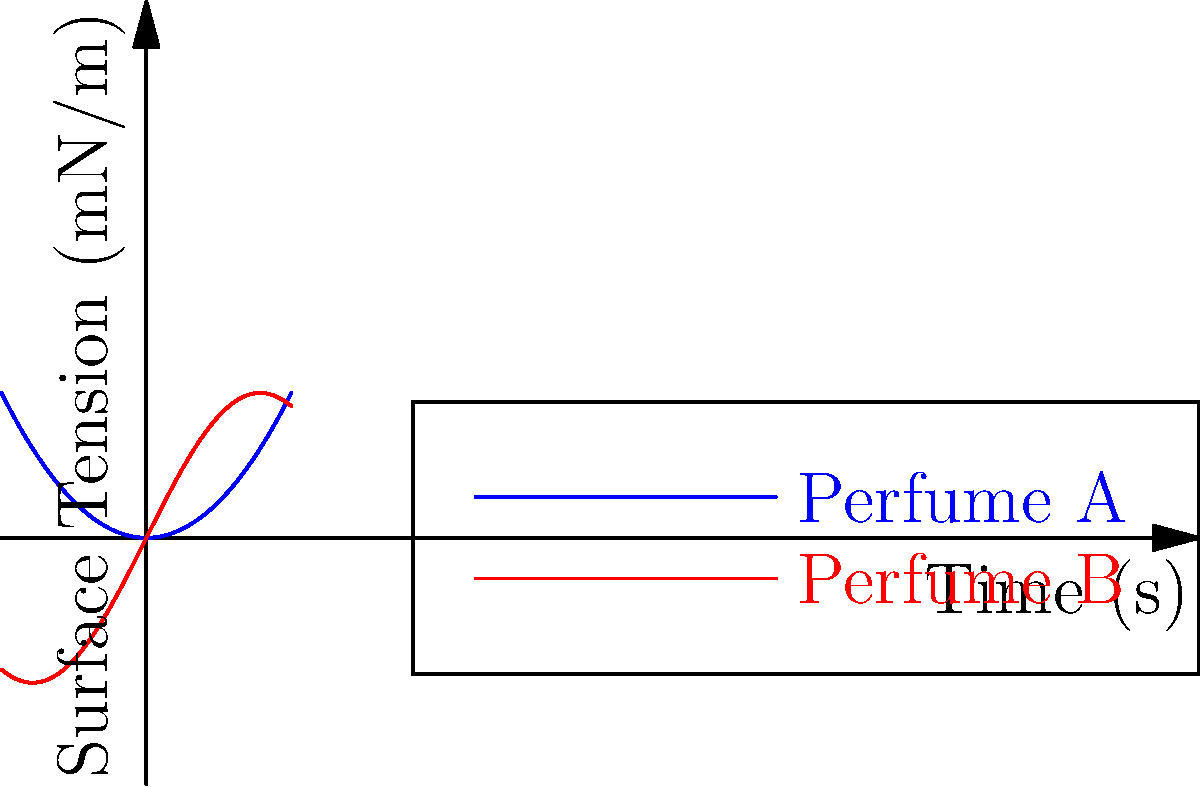The graph shows the surface tension measurements of two perfume formulations over time using the pendant drop method. Which perfume formulation exhibits a more stable surface tension profile, and why is this important for the overall quality of the perfume? To determine which perfume formulation has a more stable surface tension profile, we need to analyze the graphs:

1. Perfume A (blue curve):
   - Represented by a parabolic function ($f(x) = 0.5x^2$)
   - Surface tension increases quadratically over time
   - Shows a continuous, smooth increase

2. Perfume B (red curve):
   - Represented by a sine function ($g(x) = 2\sin(x)$)
   - Surface tension oscillates periodically
   - Shows regular fluctuations

3. Stability comparison:
   - Perfume A has a predictable, steady increase in surface tension
   - Perfume B has periodic fluctuations, indicating less stability

4. Importance for perfume quality:
   - Stable surface tension contributes to consistent droplet formation
   - Affects the spray pattern and distribution of the perfume
   - Influences the perfume's interaction with the skin
   - Impacts the overall sensory experience and longevity of the fragrance

5. Conclusion:
   Perfume A exhibits a more stable surface tension profile, which is crucial for maintaining consistent quality, spray characteristics, and user experience in the final perfume product.
Answer: Perfume A; stable surface tension ensures consistent spray quality and fragrance performance. 